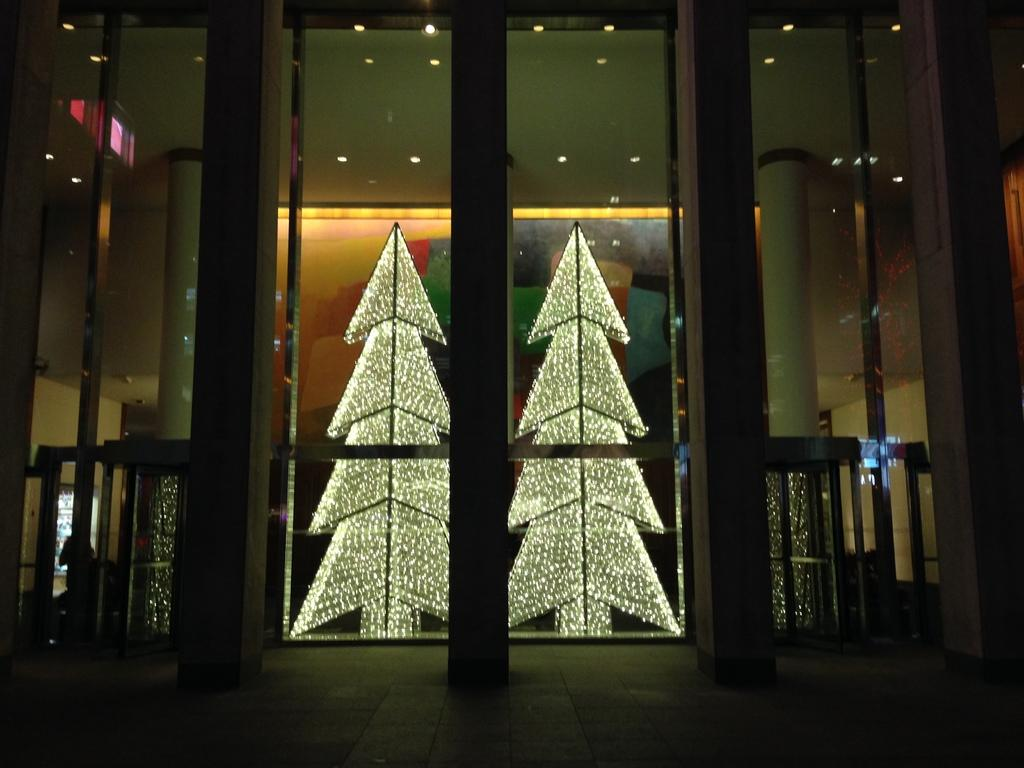What is the main structure visible in the image? There is a building in the image. What is located in the foreground of the image? There is a glass court in the foreground of the image. What feature does the glass court have? The glass court has a door. What can be seen inside the door? There are lights and pillars inside the door. Can you describe the person in the background of the image? There is a person in the background of the image, but no specific details are provided. What type of eye can be seen driving the glass court in the image? There is no eye or driving activity present in the image. The glass court is stationary, and no vehicles or driving are depicted. 